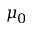<formula> <loc_0><loc_0><loc_500><loc_500>\mu _ { 0 }</formula> 